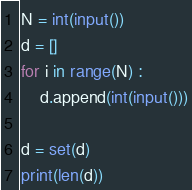Convert code to text. <code><loc_0><loc_0><loc_500><loc_500><_Python_>N = int(input())
d = []
for i in range(N) :
	d.append(int(input()))

d = set(d)
print(len(d))</code> 